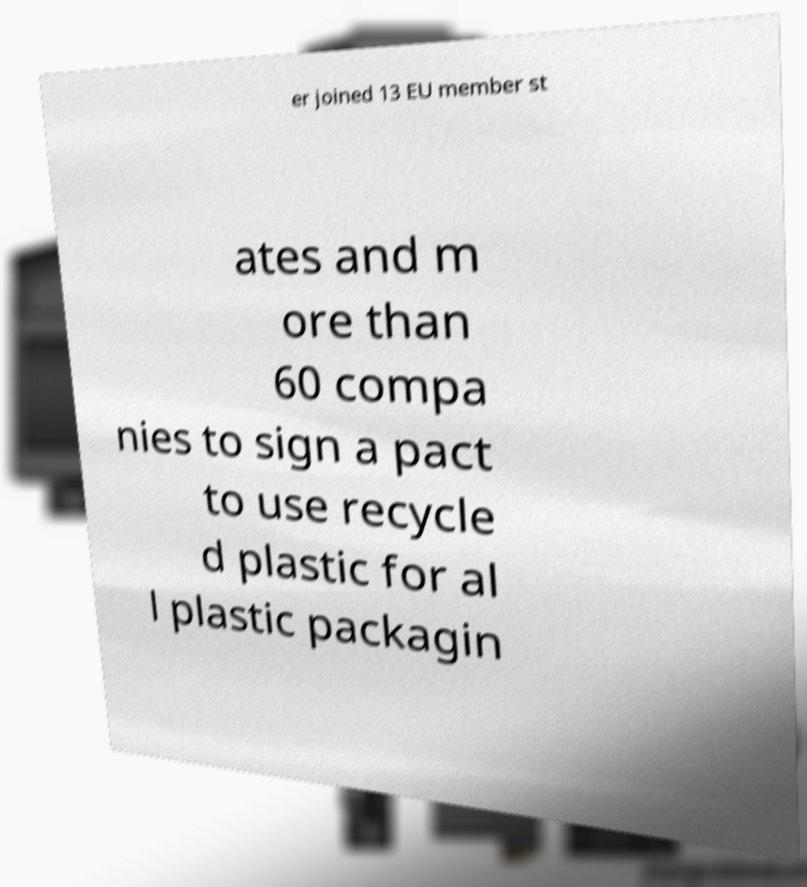Can you read and provide the text displayed in the image?This photo seems to have some interesting text. Can you extract and type it out for me? er joined 13 EU member st ates and m ore than 60 compa nies to sign a pact to use recycle d plastic for al l plastic packagin 